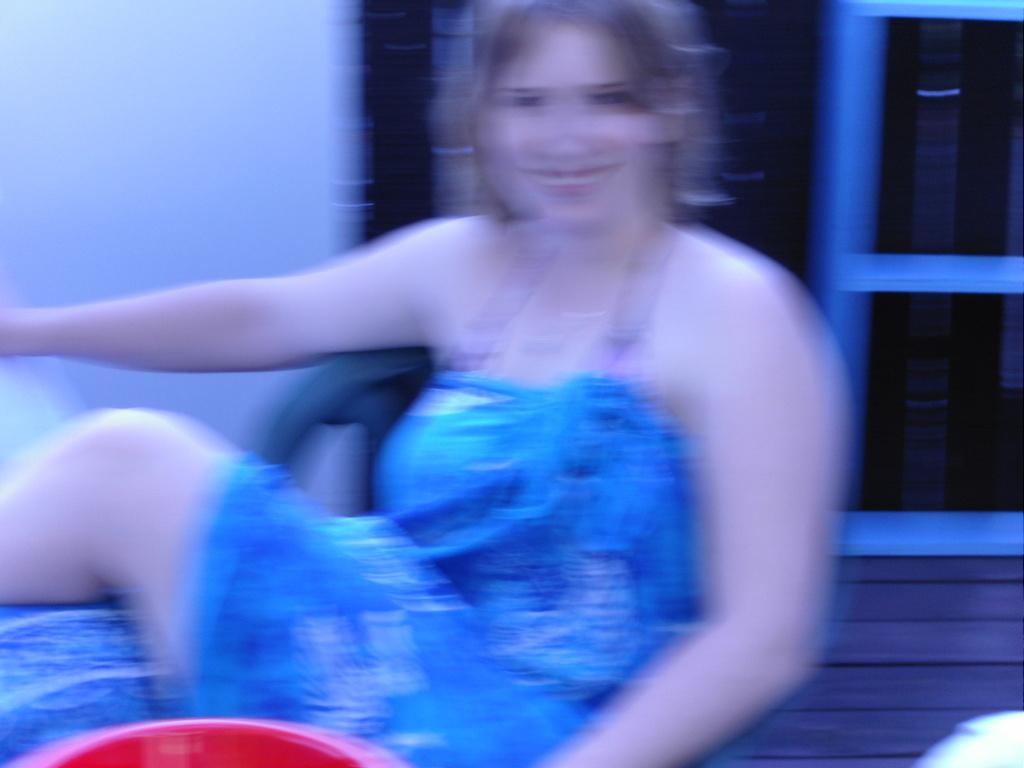What is the main subject of the image? There is a woman in the image. What is the woman wearing? The woman is wearing a blue dress. Can you see a pail in the woman's hand in the image? There is no pail visible in the woman's hand in the image. What type of bird is perched on the woman's shoulder in the image? There is no bird, specifically a robin, present in the image. 